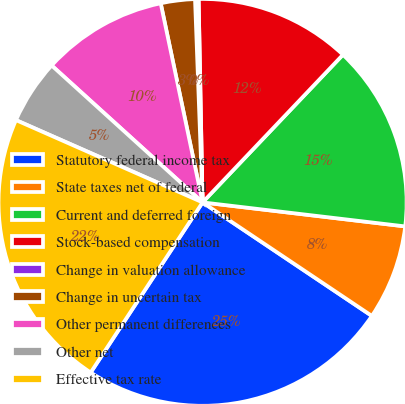Convert chart to OTSL. <chart><loc_0><loc_0><loc_500><loc_500><pie_chart><fcel>Statutory federal income tax<fcel>State taxes net of federal<fcel>Current and deferred foreign<fcel>Stock-based compensation<fcel>Change in valuation allowance<fcel>Change in uncertain tax<fcel>Other permanent differences<fcel>Other net<fcel>Effective tax rate<nl><fcel>24.81%<fcel>7.54%<fcel>14.81%<fcel>12.38%<fcel>0.28%<fcel>2.7%<fcel>9.96%<fcel>5.12%<fcel>22.39%<nl></chart> 